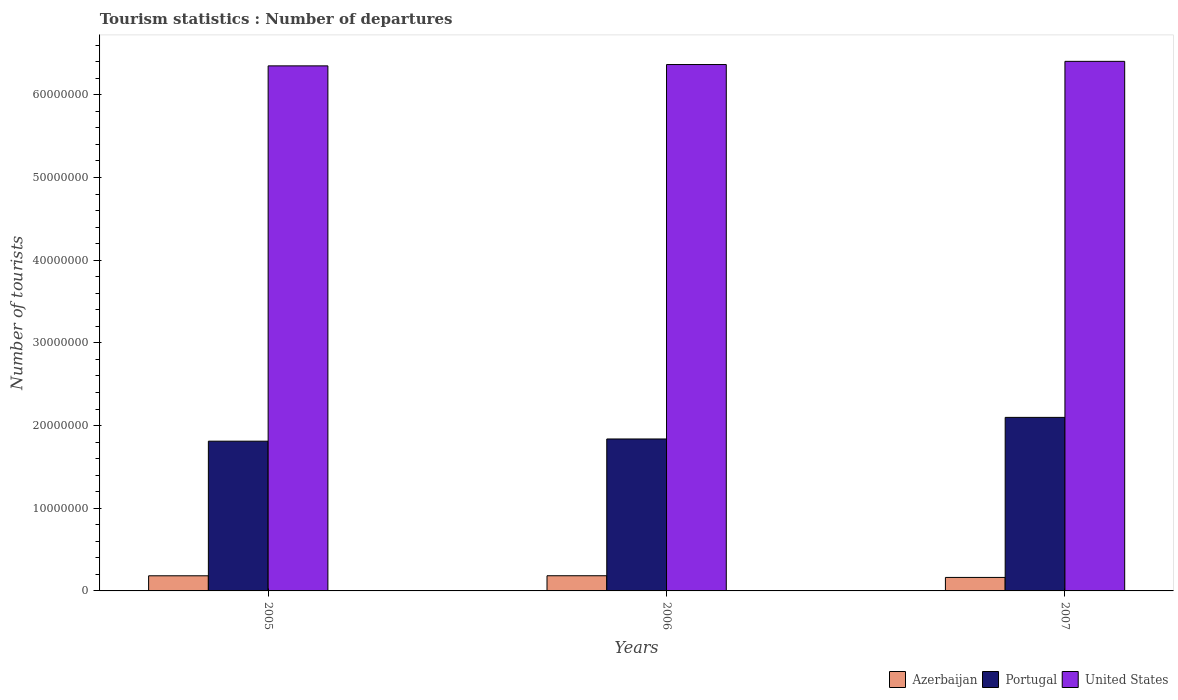How many groups of bars are there?
Keep it short and to the point. 3. Are the number of bars on each tick of the X-axis equal?
Keep it short and to the point. Yes. How many bars are there on the 1st tick from the left?
Provide a short and direct response. 3. In how many cases, is the number of bars for a given year not equal to the number of legend labels?
Your answer should be compact. 0. What is the number of tourist departures in United States in 2005?
Your answer should be compact. 6.35e+07. Across all years, what is the maximum number of tourist departures in United States?
Offer a very short reply. 6.40e+07. Across all years, what is the minimum number of tourist departures in Portugal?
Provide a succinct answer. 1.81e+07. In which year was the number of tourist departures in Portugal maximum?
Offer a terse response. 2007. What is the total number of tourist departures in United States in the graph?
Your answer should be very brief. 1.91e+08. What is the difference between the number of tourist departures in United States in 2005 and that in 2006?
Provide a succinct answer. -1.60e+05. What is the difference between the number of tourist departures in Portugal in 2007 and the number of tourist departures in Azerbaijan in 2006?
Keep it short and to the point. 1.92e+07. What is the average number of tourist departures in Portugal per year?
Your answer should be compact. 1.92e+07. In the year 2007, what is the difference between the number of tourist departures in Azerbaijan and number of tourist departures in United States?
Make the answer very short. -6.24e+07. In how many years, is the number of tourist departures in United States greater than 6000000?
Keep it short and to the point. 3. What is the ratio of the number of tourist departures in Portugal in 2005 to that in 2006?
Keep it short and to the point. 0.99. Is the number of tourist departures in Portugal in 2005 less than that in 2007?
Your answer should be very brief. Yes. Is the difference between the number of tourist departures in Azerbaijan in 2005 and 2007 greater than the difference between the number of tourist departures in United States in 2005 and 2007?
Provide a short and direct response. Yes. What is the difference between the highest and the second highest number of tourist departures in Portugal?
Offer a terse response. 2.61e+06. What is the difference between the highest and the lowest number of tourist departures in United States?
Give a very brief answer. 5.46e+05. What does the 1st bar from the left in 2007 represents?
Offer a terse response. Azerbaijan. Is it the case that in every year, the sum of the number of tourist departures in Portugal and number of tourist departures in United States is greater than the number of tourist departures in Azerbaijan?
Offer a terse response. Yes. Are all the bars in the graph horizontal?
Ensure brevity in your answer.  No. Are the values on the major ticks of Y-axis written in scientific E-notation?
Offer a terse response. No. Does the graph contain grids?
Provide a succinct answer. No. How are the legend labels stacked?
Provide a short and direct response. Horizontal. What is the title of the graph?
Your response must be concise. Tourism statistics : Number of departures. Does "Philippines" appear as one of the legend labels in the graph?
Offer a terse response. No. What is the label or title of the Y-axis?
Your answer should be very brief. Number of tourists. What is the Number of tourists of Azerbaijan in 2005?
Your answer should be compact. 1.83e+06. What is the Number of tourists of Portugal in 2005?
Offer a very short reply. 1.81e+07. What is the Number of tourists in United States in 2005?
Offer a terse response. 6.35e+07. What is the Number of tourists of Azerbaijan in 2006?
Your response must be concise. 1.84e+06. What is the Number of tourists of Portugal in 2006?
Offer a very short reply. 1.84e+07. What is the Number of tourists in United States in 2006?
Keep it short and to the point. 6.37e+07. What is the Number of tourists of Azerbaijan in 2007?
Give a very brief answer. 1.63e+06. What is the Number of tourists in Portugal in 2007?
Provide a succinct answer. 2.10e+07. What is the Number of tourists of United States in 2007?
Your answer should be compact. 6.40e+07. Across all years, what is the maximum Number of tourists of Azerbaijan?
Your answer should be compact. 1.84e+06. Across all years, what is the maximum Number of tourists in Portugal?
Keep it short and to the point. 2.10e+07. Across all years, what is the maximum Number of tourists in United States?
Your response must be concise. 6.40e+07. Across all years, what is the minimum Number of tourists of Azerbaijan?
Ensure brevity in your answer.  1.63e+06. Across all years, what is the minimum Number of tourists of Portugal?
Keep it short and to the point. 1.81e+07. Across all years, what is the minimum Number of tourists in United States?
Offer a very short reply. 6.35e+07. What is the total Number of tourists in Azerbaijan in the graph?
Offer a very short reply. 5.30e+06. What is the total Number of tourists in Portugal in the graph?
Provide a succinct answer. 5.75e+07. What is the total Number of tourists in United States in the graph?
Provide a succinct answer. 1.91e+08. What is the difference between the Number of tourists in Azerbaijan in 2005 and that in 2006?
Make the answer very short. -6000. What is the difference between the Number of tourists of Portugal in 2005 and that in 2006?
Offer a very short reply. -2.68e+05. What is the difference between the Number of tourists in United States in 2005 and that in 2006?
Your answer should be very brief. -1.60e+05. What is the difference between the Number of tourists of Azerbaijan in 2005 and that in 2007?
Provide a short and direct response. 1.99e+05. What is the difference between the Number of tourists in Portugal in 2005 and that in 2007?
Your answer should be compact. -2.88e+06. What is the difference between the Number of tourists of United States in 2005 and that in 2007?
Give a very brief answer. -5.46e+05. What is the difference between the Number of tourists in Azerbaijan in 2006 and that in 2007?
Offer a terse response. 2.05e+05. What is the difference between the Number of tourists of Portugal in 2006 and that in 2007?
Give a very brief answer. -2.61e+06. What is the difference between the Number of tourists in United States in 2006 and that in 2007?
Offer a terse response. -3.86e+05. What is the difference between the Number of tourists of Azerbaijan in 2005 and the Number of tourists of Portugal in 2006?
Offer a very short reply. -1.65e+07. What is the difference between the Number of tourists in Azerbaijan in 2005 and the Number of tourists in United States in 2006?
Offer a very short reply. -6.18e+07. What is the difference between the Number of tourists in Portugal in 2005 and the Number of tourists in United States in 2006?
Provide a succinct answer. -4.56e+07. What is the difference between the Number of tourists of Azerbaijan in 2005 and the Number of tourists of Portugal in 2007?
Make the answer very short. -1.92e+07. What is the difference between the Number of tourists of Azerbaijan in 2005 and the Number of tourists of United States in 2007?
Keep it short and to the point. -6.22e+07. What is the difference between the Number of tourists of Portugal in 2005 and the Number of tourists of United States in 2007?
Ensure brevity in your answer.  -4.59e+07. What is the difference between the Number of tourists of Azerbaijan in 2006 and the Number of tourists of Portugal in 2007?
Give a very brief answer. -1.92e+07. What is the difference between the Number of tourists of Azerbaijan in 2006 and the Number of tourists of United States in 2007?
Ensure brevity in your answer.  -6.22e+07. What is the difference between the Number of tourists in Portugal in 2006 and the Number of tourists in United States in 2007?
Ensure brevity in your answer.  -4.57e+07. What is the average Number of tourists of Azerbaijan per year?
Ensure brevity in your answer.  1.77e+06. What is the average Number of tourists in Portugal per year?
Your answer should be very brief. 1.92e+07. What is the average Number of tourists of United States per year?
Give a very brief answer. 6.37e+07. In the year 2005, what is the difference between the Number of tourists of Azerbaijan and Number of tourists of Portugal?
Your response must be concise. -1.63e+07. In the year 2005, what is the difference between the Number of tourists of Azerbaijan and Number of tourists of United States?
Your answer should be compact. -6.17e+07. In the year 2005, what is the difference between the Number of tourists in Portugal and Number of tourists in United States?
Ensure brevity in your answer.  -4.54e+07. In the year 2006, what is the difference between the Number of tourists in Azerbaijan and Number of tourists in Portugal?
Provide a succinct answer. -1.65e+07. In the year 2006, what is the difference between the Number of tourists in Azerbaijan and Number of tourists in United States?
Your answer should be very brief. -6.18e+07. In the year 2006, what is the difference between the Number of tourists in Portugal and Number of tourists in United States?
Offer a terse response. -4.53e+07. In the year 2007, what is the difference between the Number of tourists in Azerbaijan and Number of tourists in Portugal?
Provide a succinct answer. -1.94e+07. In the year 2007, what is the difference between the Number of tourists of Azerbaijan and Number of tourists of United States?
Provide a succinct answer. -6.24e+07. In the year 2007, what is the difference between the Number of tourists in Portugal and Number of tourists in United States?
Your answer should be very brief. -4.31e+07. What is the ratio of the Number of tourists in Portugal in 2005 to that in 2006?
Keep it short and to the point. 0.99. What is the ratio of the Number of tourists of United States in 2005 to that in 2006?
Give a very brief answer. 1. What is the ratio of the Number of tourists of Azerbaijan in 2005 to that in 2007?
Your answer should be very brief. 1.12. What is the ratio of the Number of tourists in Portugal in 2005 to that in 2007?
Ensure brevity in your answer.  0.86. What is the ratio of the Number of tourists in United States in 2005 to that in 2007?
Keep it short and to the point. 0.99. What is the ratio of the Number of tourists in Azerbaijan in 2006 to that in 2007?
Provide a succinct answer. 1.13. What is the ratio of the Number of tourists in Portugal in 2006 to that in 2007?
Give a very brief answer. 0.88. What is the difference between the highest and the second highest Number of tourists of Azerbaijan?
Offer a terse response. 6000. What is the difference between the highest and the second highest Number of tourists in Portugal?
Your answer should be compact. 2.61e+06. What is the difference between the highest and the second highest Number of tourists of United States?
Give a very brief answer. 3.86e+05. What is the difference between the highest and the lowest Number of tourists of Azerbaijan?
Ensure brevity in your answer.  2.05e+05. What is the difference between the highest and the lowest Number of tourists of Portugal?
Provide a short and direct response. 2.88e+06. What is the difference between the highest and the lowest Number of tourists in United States?
Offer a terse response. 5.46e+05. 